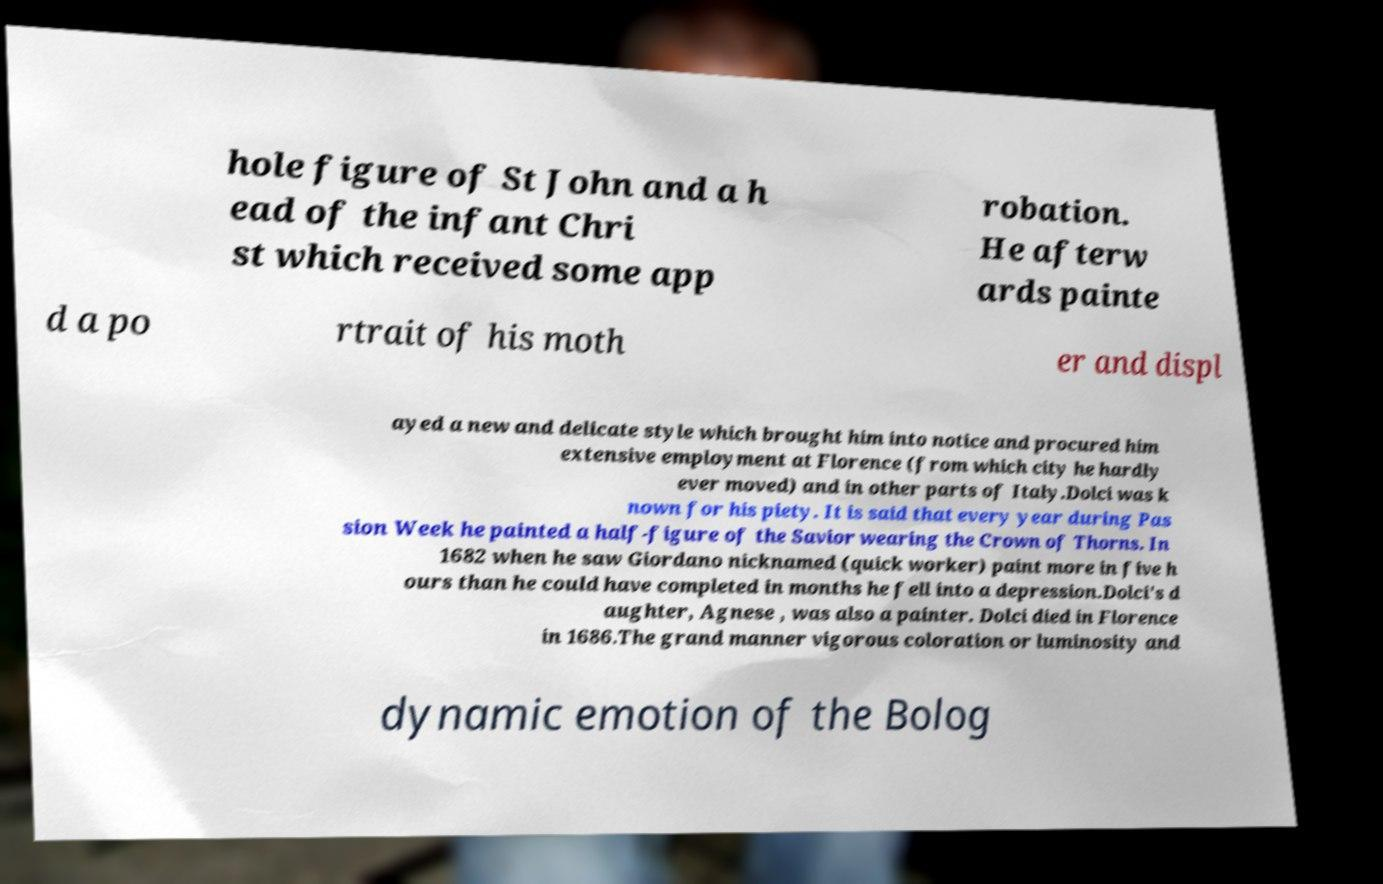For documentation purposes, I need the text within this image transcribed. Could you provide that? hole figure of St John and a h ead of the infant Chri st which received some app robation. He afterw ards painte d a po rtrait of his moth er and displ ayed a new and delicate style which brought him into notice and procured him extensive employment at Florence (from which city he hardly ever moved) and in other parts of Italy.Dolci was k nown for his piety. It is said that every year during Pas sion Week he painted a half-figure of the Savior wearing the Crown of Thorns. In 1682 when he saw Giordano nicknamed (quick worker) paint more in five h ours than he could have completed in months he fell into a depression.Dolci's d aughter, Agnese , was also a painter. Dolci died in Florence in 1686.The grand manner vigorous coloration or luminosity and dynamic emotion of the Bolog 